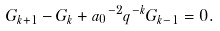Convert formula to latex. <formula><loc_0><loc_0><loc_500><loc_500>G _ { k + 1 } - G _ { k } + { a _ { 0 } } ^ { - 2 } q ^ { - k } G _ { k - 1 } = 0 .</formula> 